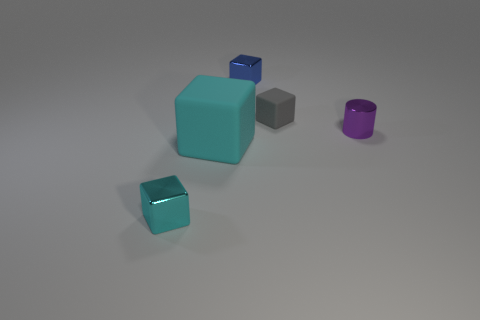What number of other things are there of the same material as the small blue thing
Offer a terse response. 2. There is a tiny block to the left of the tiny blue cube; what color is it?
Offer a terse response. Cyan. There is a tiny block to the right of the small blue metallic block on the right side of the rubber block left of the small rubber cube; what is it made of?
Ensure brevity in your answer.  Rubber. Are there any tiny green rubber objects of the same shape as the tiny gray thing?
Your answer should be compact. No. There is a blue metal object that is the same size as the purple thing; what shape is it?
Keep it short and to the point. Cube. What number of cubes are both left of the blue metal object and behind the tiny cyan block?
Keep it short and to the point. 1. Is the number of matte things that are right of the tiny gray rubber object less than the number of blue metallic objects?
Offer a very short reply. Yes. Are there any other cubes of the same size as the cyan rubber block?
Your answer should be very brief. No. The small block that is the same material as the large cube is what color?
Your response must be concise. Gray. How many small cylinders are to the left of the cyan block that is right of the tiny cyan object?
Give a very brief answer. 0. 